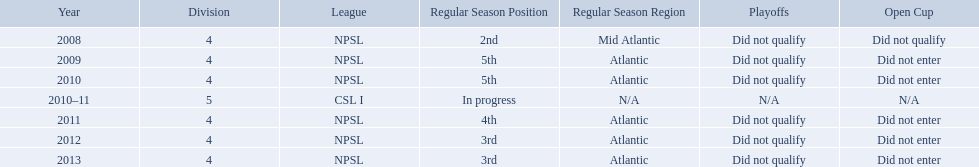What are all of the leagues? NPSL, NPSL, NPSL, CSL I, NPSL, NPSL, NPSL. Which league was played in the least? CSL I. What are the names of the leagues? NPSL, CSL I. Which league other than npsl did ny soccer team play under? CSL I. 